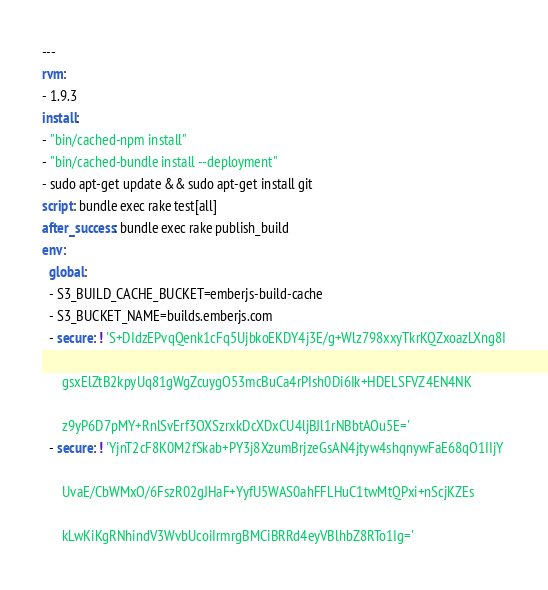Convert code to text. <code><loc_0><loc_0><loc_500><loc_500><_YAML_>---
rvm:
- 1.9.3
install:
- "bin/cached-npm install"
- "bin/cached-bundle install --deployment"
- sudo apt-get update && sudo apt-get install git
script: bundle exec rake test[all]
after_success: bundle exec rake publish_build
env:
  global:
  - S3_BUILD_CACHE_BUCKET=emberjs-build-cache
  - S3_BUCKET_NAME=builds.emberjs.com
  - secure: ! 'S+DIdzEPvqQenk1cFq5UjbkoEKDY4j3E/g+Wlz798xxyTkrKQZxoazLXng8I

      gsxElZtB2kpyUq81gWgZcuygO53mcBuCa4rPIsh0Di6Ik+HDELSFVZ4EN4NK

      z9yP6D7pMY+RnlSvErf3OXSzrxkDcXDxCU4ljBJl1rNBbtAOu5E='
  - secure: ! 'YjnT2cF8K0M2fSkab+PY3j8XzumBrjzeGsAN4jtyw4shqnywFaE68qO1IIjY

      UvaE/CbWMxO/6FszR02gJHaF+YyfU5WAS0ahFFLHuC1twMtQPxi+nScjKZEs

      kLwKiKgRNhindV3WvbUcoiIrmrgBMCiBRRd4eyVBlhbZ8RTo1Ig='
</code> 